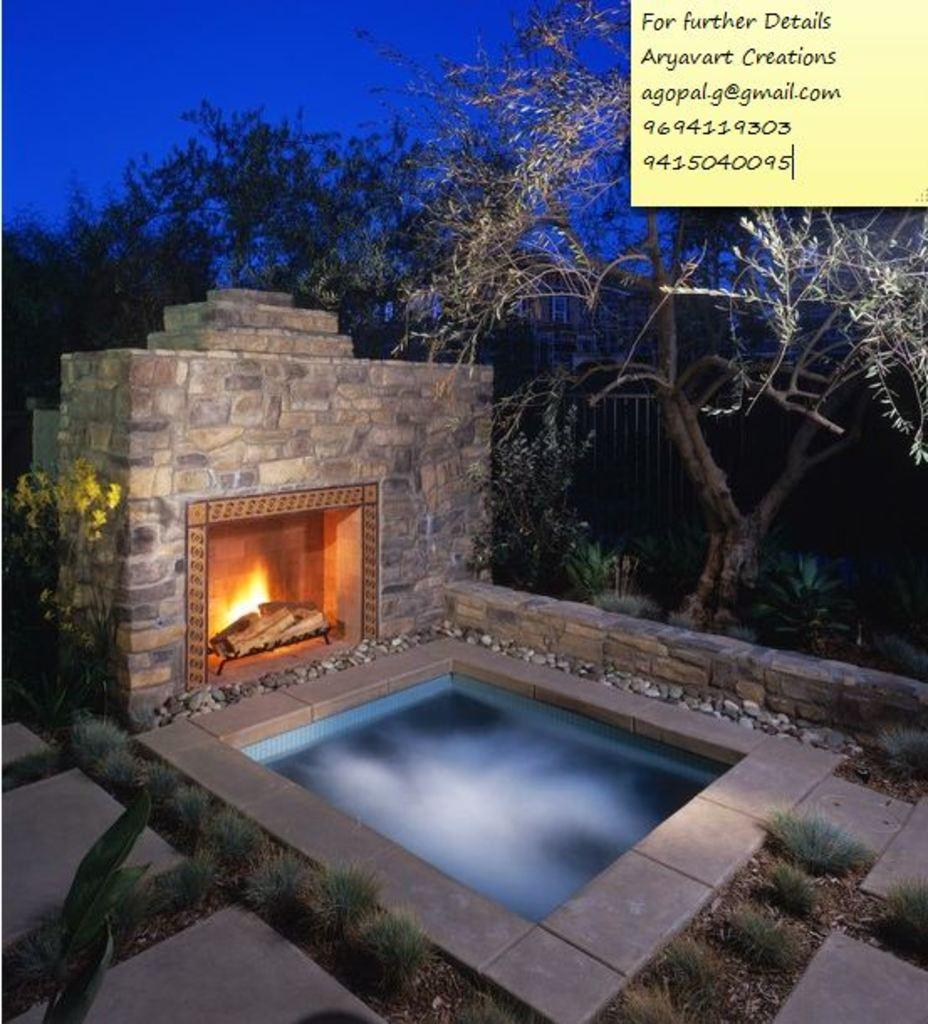What type of body of water is present in the image? There is a pond in the image. What is the source of light and heat in the image? There is a campfire in the image. Where is the campfire located in relation to the pond? The campfire is located near the pond. What type of vegetation can be seen in the image? There are trees and plants in the image. How many chickens are roaming around the campfire in the image? There are no chickens present in the image. What type of experience can be gained from the image? The image does not convey a specific experience; it is a visual representation of a pond, campfire, trees, and plants. 